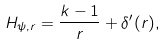<formula> <loc_0><loc_0><loc_500><loc_500>H _ { \psi , r } = \frac { k - 1 } { r } + \delta ^ { \prime } ( r ) ,</formula> 